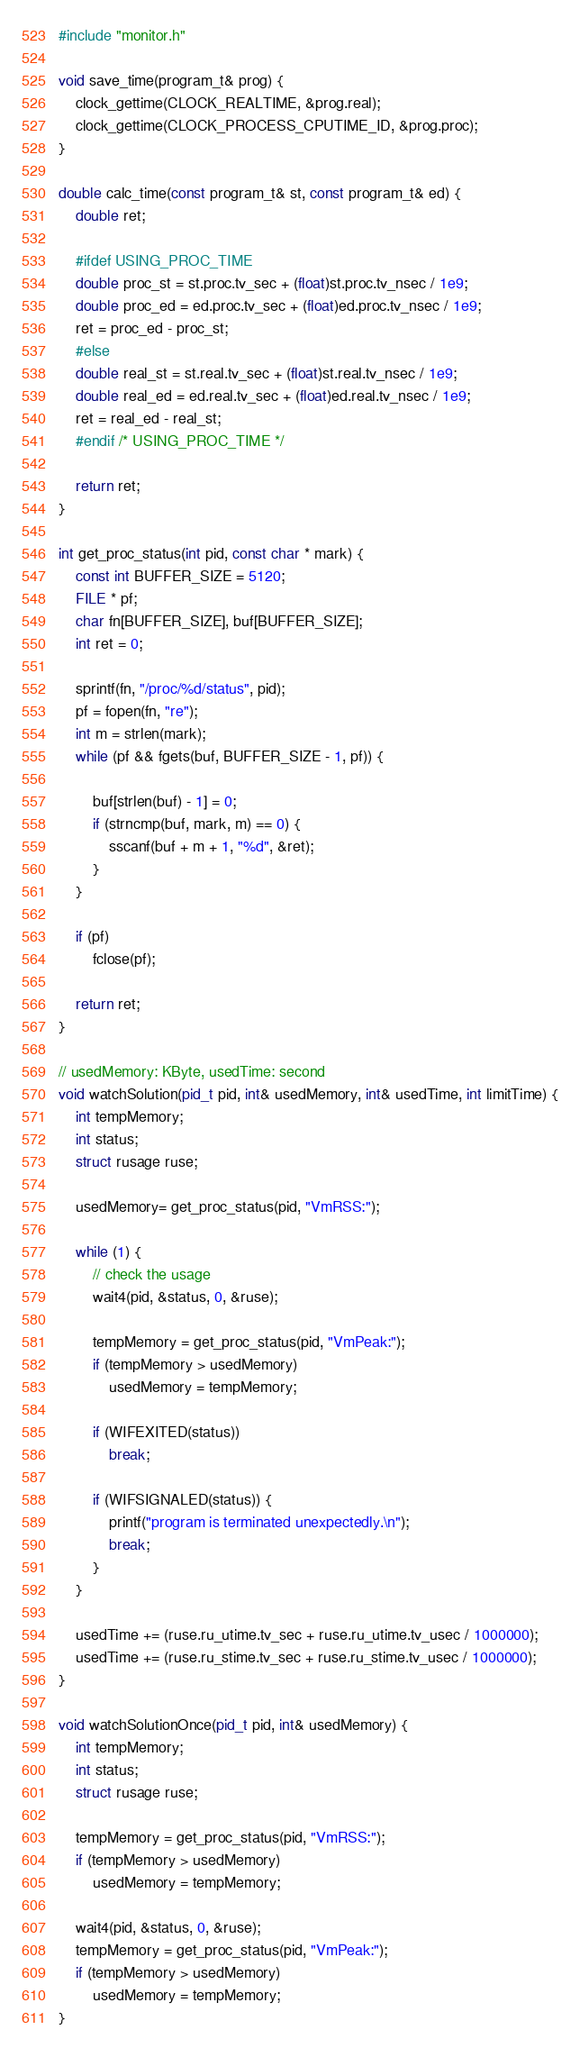<code> <loc_0><loc_0><loc_500><loc_500><_C++_>#include "monitor.h"

void save_time(program_t& prog) {
	clock_gettime(CLOCK_REALTIME, &prog.real);
	clock_gettime(CLOCK_PROCESS_CPUTIME_ID, &prog.proc);
}

double calc_time(const program_t& st, const program_t& ed) {
	double ret;

	#ifdef USING_PROC_TIME
	double proc_st = st.proc.tv_sec + (float)st.proc.tv_nsec / 1e9;
	double proc_ed = ed.proc.tv_sec + (float)ed.proc.tv_nsec / 1e9;
	ret = proc_ed - proc_st;
	#else
	double real_st = st.real.tv_sec + (float)st.real.tv_nsec / 1e9;
	double real_ed = ed.real.tv_sec + (float)ed.real.tv_nsec / 1e9;
	ret = real_ed - real_st;
	#endif /* USING_PROC_TIME */

	return ret;
}

int get_proc_status(int pid, const char * mark) {
	const int BUFFER_SIZE = 5120;
	FILE * pf;
	char fn[BUFFER_SIZE], buf[BUFFER_SIZE];
	int ret = 0;

	sprintf(fn, "/proc/%d/status", pid);
	pf = fopen(fn, "re");
	int m = strlen(mark);
	while (pf && fgets(buf, BUFFER_SIZE - 1, pf)) {

		buf[strlen(buf) - 1] = 0;
		if (strncmp(buf, mark, m) == 0) {
			sscanf(buf + m + 1, "%d", &ret);
		}
	}

	if (pf)
		fclose(pf);

	return ret;
}

// usedMemory: KByte, usedTime: second
void watchSolution(pid_t pid, int& usedMemory, int& usedTime, int limitTime) {
	int tempMemory;
	int status;
	struct rusage ruse;

	usedMemory= get_proc_status(pid, "VmRSS:");

	while (1) {
		// check the usage
		wait4(pid, &status, 0, &ruse);

		tempMemory = get_proc_status(pid, "VmPeak:");
		if (tempMemory > usedMemory)
			usedMemory = tempMemory;

		if (WIFEXITED(status))
			break;

		if (WIFSIGNALED(status)) {
			printf("program is terminated unexpectedly.\n");
			break;
		}
	}

	usedTime += (ruse.ru_utime.tv_sec + ruse.ru_utime.tv_usec / 1000000);
	usedTime += (ruse.ru_stime.tv_sec + ruse.ru_stime.tv_usec / 1000000);
}

void watchSolutionOnce(pid_t pid, int& usedMemory) {
	int tempMemory;
	int status;
	struct rusage ruse;

	tempMemory = get_proc_status(pid, "VmRSS:");
	if (tempMemory > usedMemory)
		usedMemory = tempMemory;
	
	wait4(pid, &status, 0, &ruse);
	tempMemory = get_proc_status(pid, "VmPeak:");
	if (tempMemory > usedMemory)
		usedMemory = tempMemory;
}</code> 